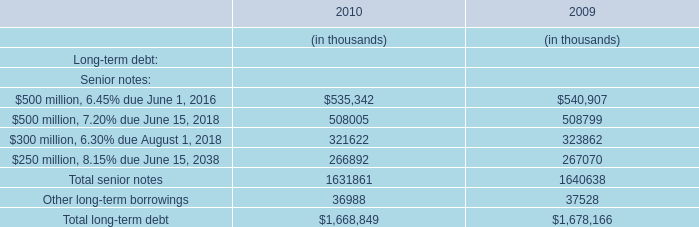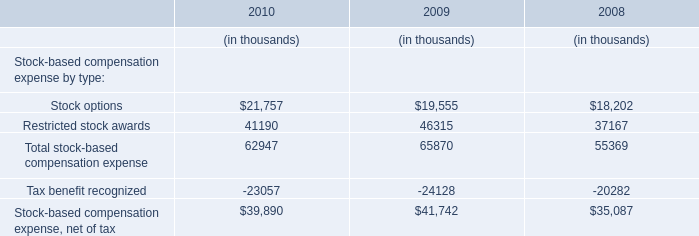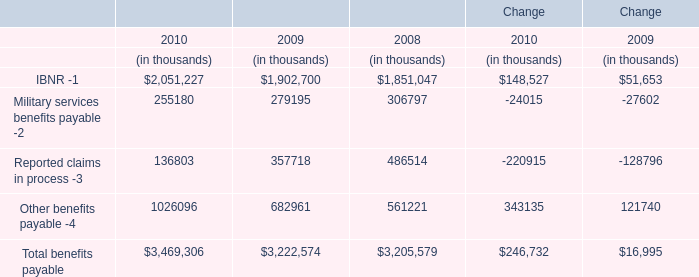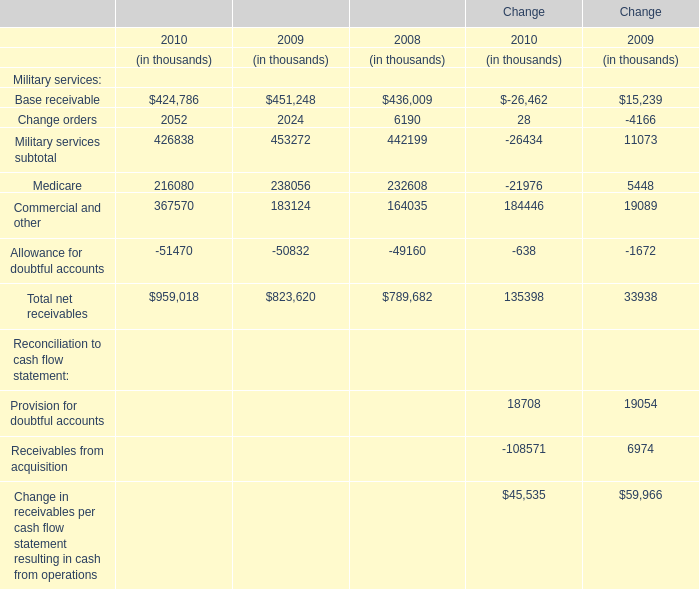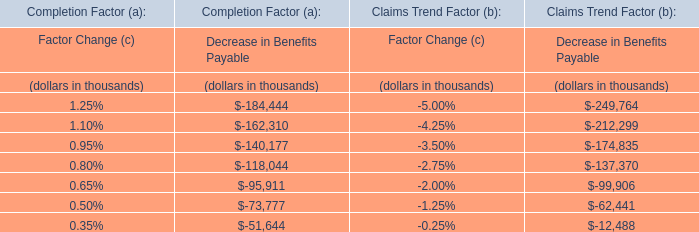What is the ratio of all elements that are smaller than 200000 to the sum of elements in 2008? 
Computations: (((6190 + 164035) - 49160) / 789682)
Answer: 0.15331. 